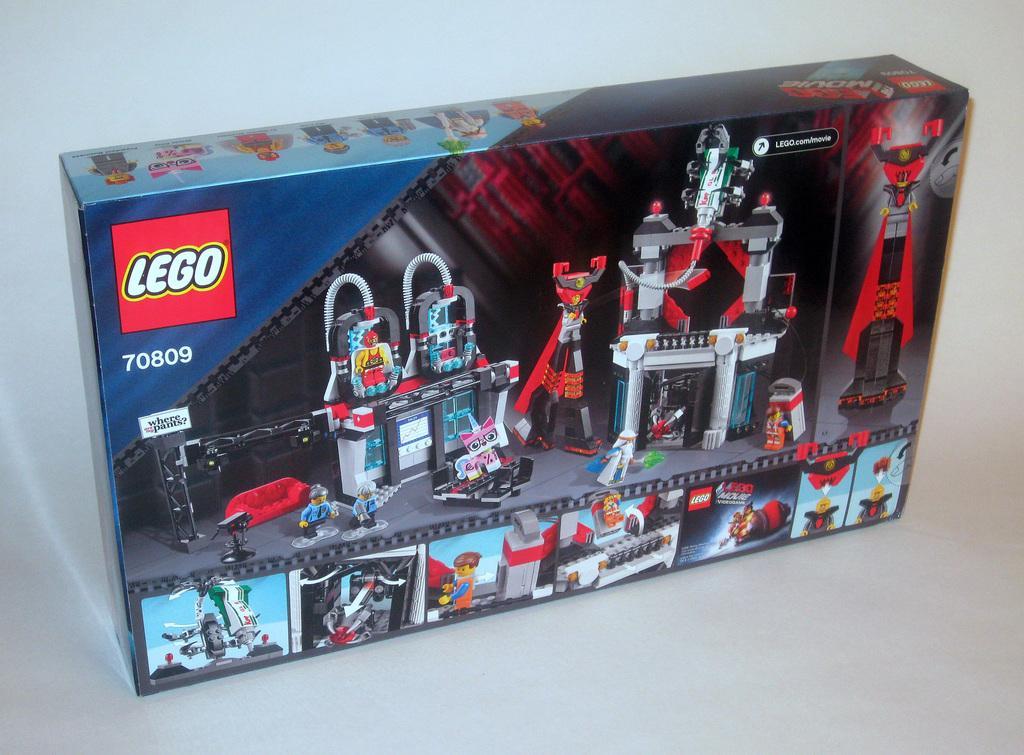In one or two sentences, can you explain what this image depicts? In this image there is a toy box in which there are Lego toys. There are so many images of the toys on the box. On the left side top corner of the box there is some text. 